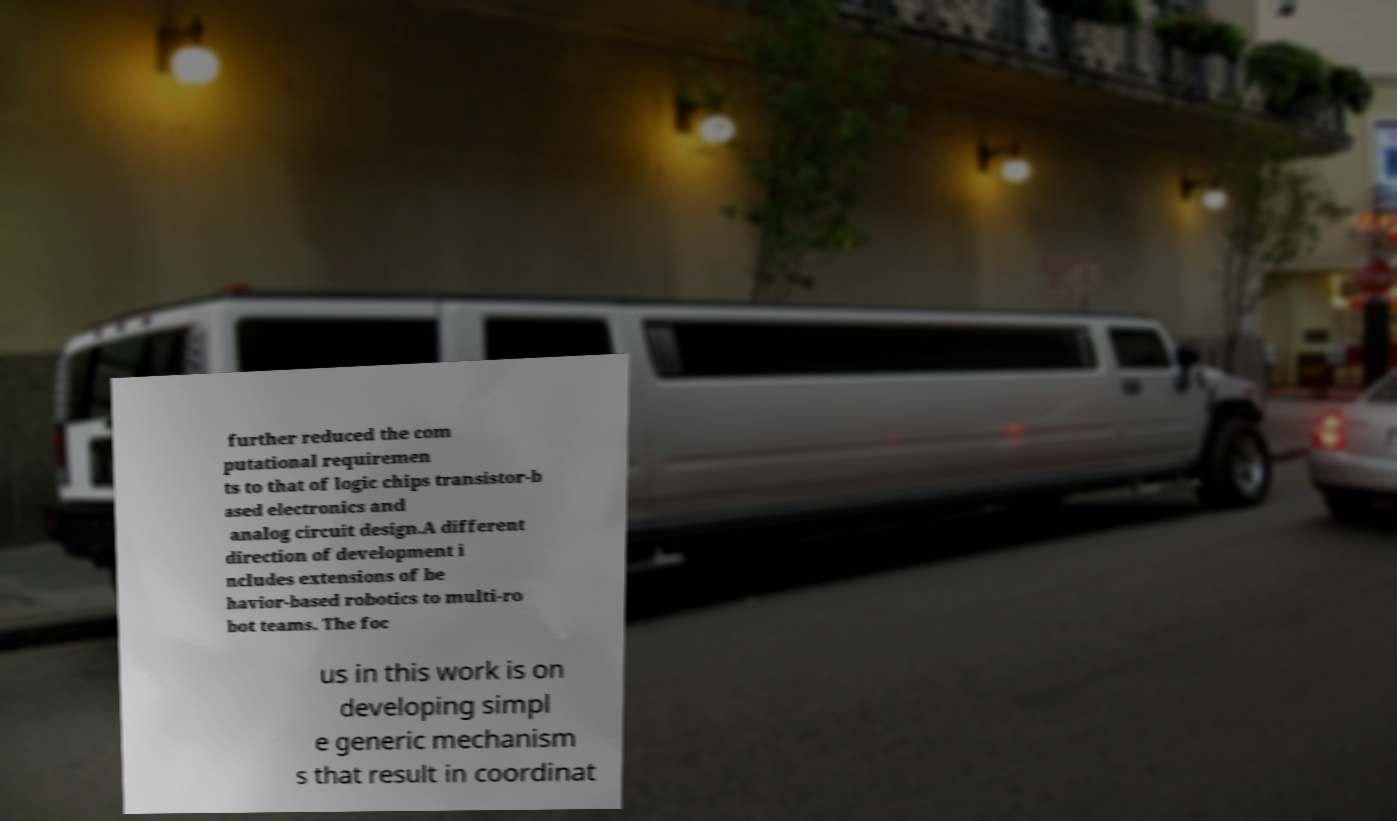Can you read and provide the text displayed in the image?This photo seems to have some interesting text. Can you extract and type it out for me? further reduced the com putational requiremen ts to that of logic chips transistor-b ased electronics and analog circuit design.A different direction of development i ncludes extensions of be havior-based robotics to multi-ro bot teams. The foc us in this work is on developing simpl e generic mechanism s that result in coordinat 